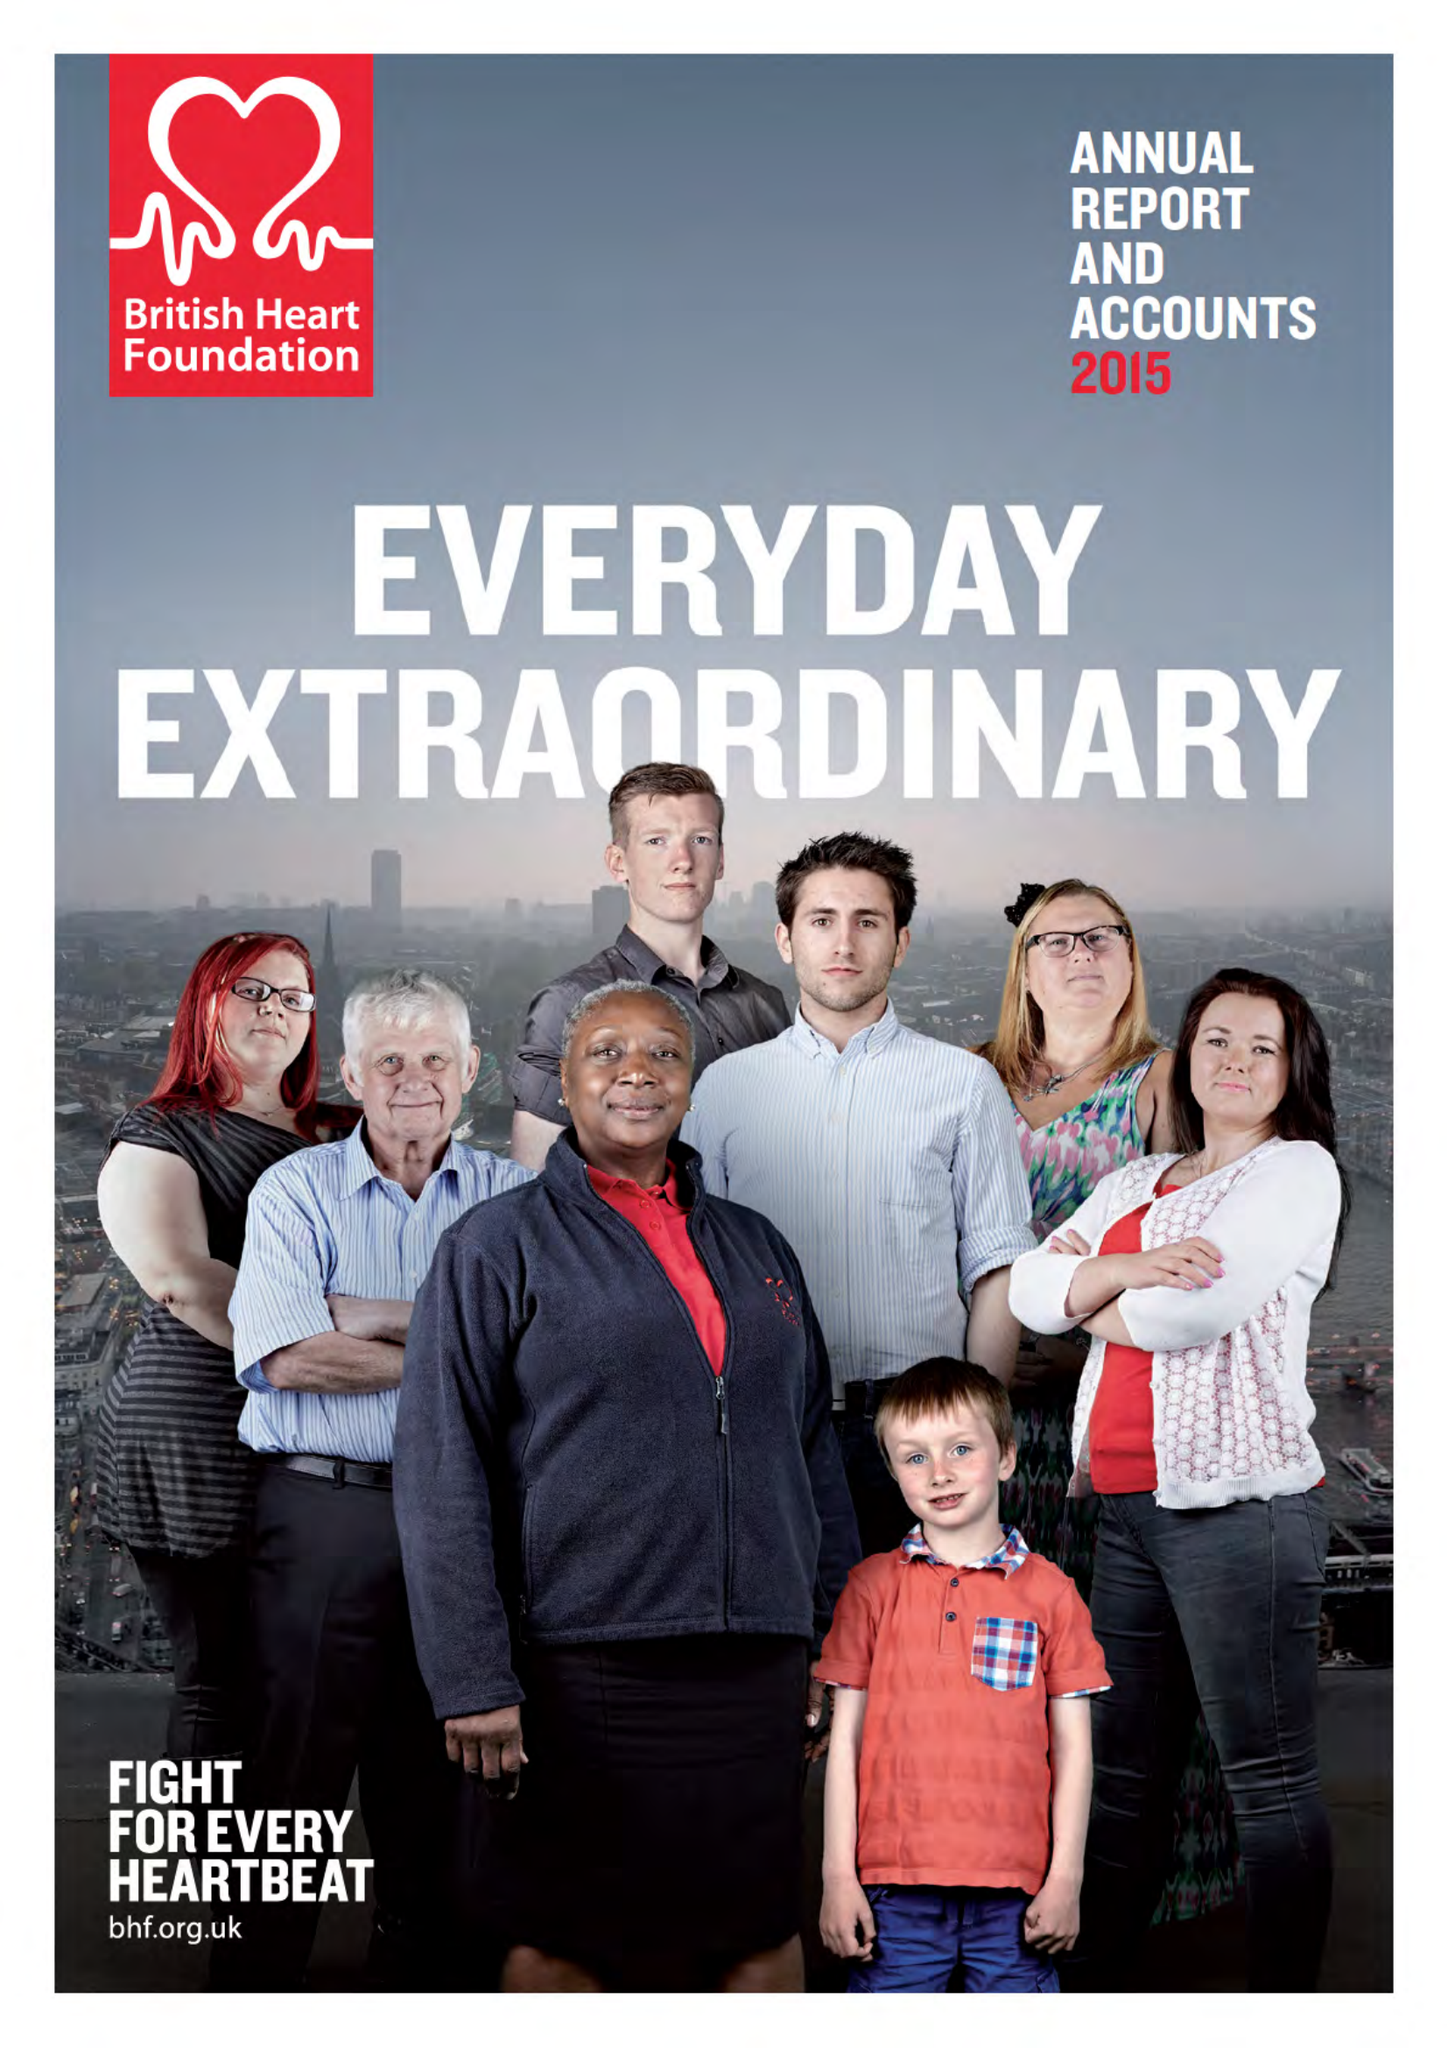What is the value for the address__postcode?
Answer the question using a single word or phrase. NW1 7AW 